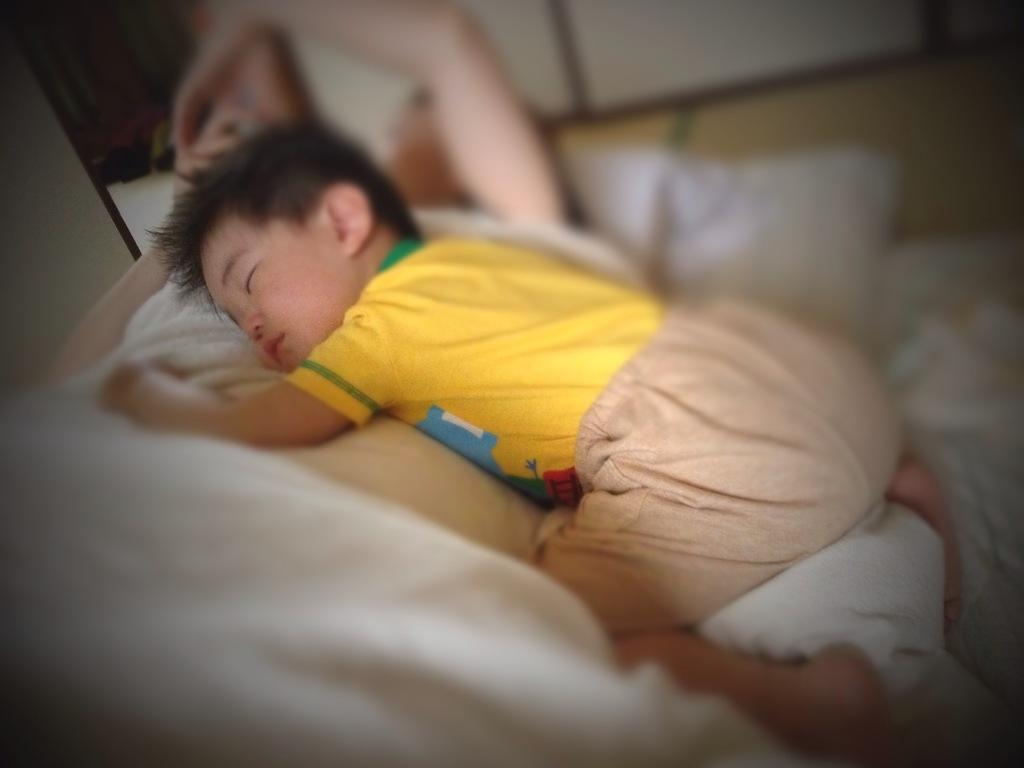What is happening in the image? There is a person in the image, and the person is sleeping. Can you describe the position or posture of the person in the image? Unfortunately, the facts provided do not give enough information to describe the position or posture of the person. What type of feeling does the bucket have in the image? There is no bucket present in the image, so it is not possible to determine any feelings it might have. 